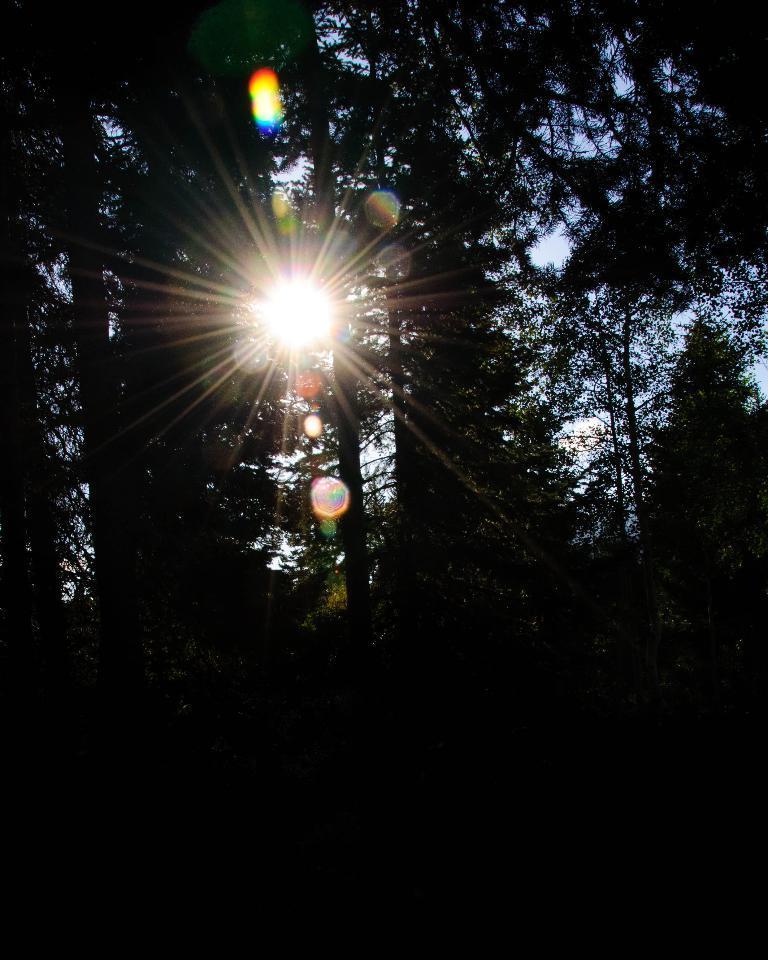Describe this image in one or two sentences. This part of the image is dark, where we can see trees. Here we can see the sun and in the background, we can see the sky. 